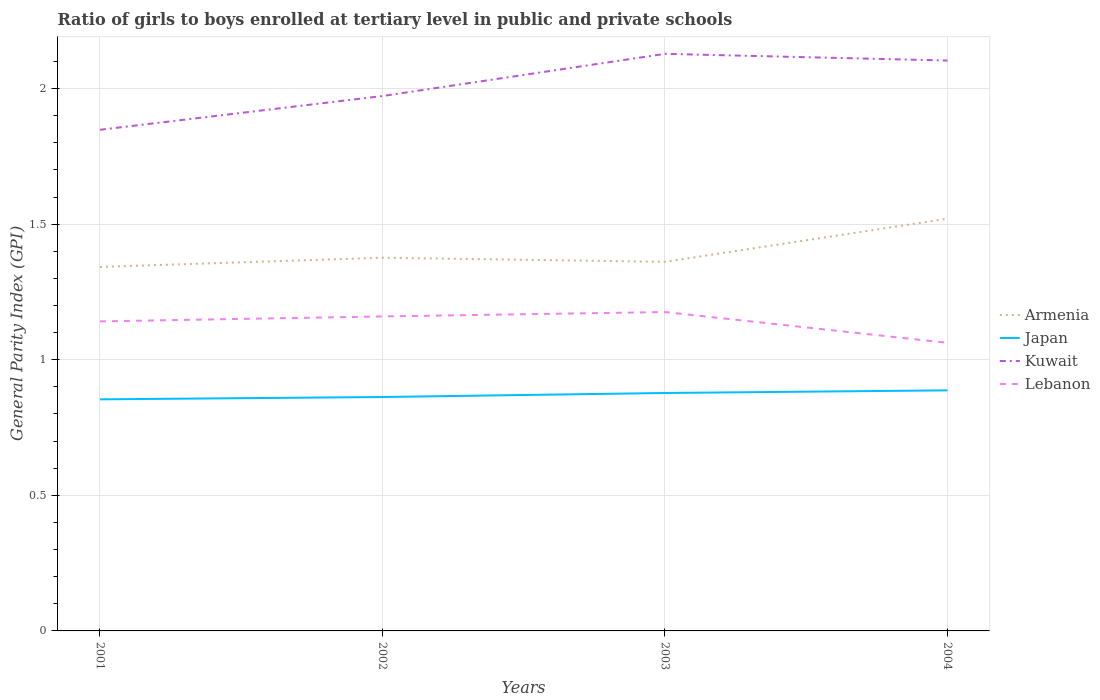Does the line corresponding to Lebanon intersect with the line corresponding to Japan?
Provide a short and direct response. No. Across all years, what is the maximum general parity index in Kuwait?
Offer a very short reply. 1.85. In which year was the general parity index in Lebanon maximum?
Your answer should be compact. 2004. What is the total general parity index in Kuwait in the graph?
Make the answer very short. -0.26. What is the difference between the highest and the second highest general parity index in Japan?
Offer a terse response. 0.03. What is the difference between the highest and the lowest general parity index in Lebanon?
Keep it short and to the point. 3. Is the general parity index in Kuwait strictly greater than the general parity index in Armenia over the years?
Offer a very short reply. No. How many lines are there?
Your answer should be compact. 4. How many years are there in the graph?
Keep it short and to the point. 4. What is the difference between two consecutive major ticks on the Y-axis?
Give a very brief answer. 0.5. Are the values on the major ticks of Y-axis written in scientific E-notation?
Your answer should be very brief. No. Does the graph contain any zero values?
Keep it short and to the point. No. Where does the legend appear in the graph?
Provide a short and direct response. Center right. How many legend labels are there?
Give a very brief answer. 4. What is the title of the graph?
Offer a terse response. Ratio of girls to boys enrolled at tertiary level in public and private schools. What is the label or title of the Y-axis?
Offer a very short reply. General Parity Index (GPI). What is the General Parity Index (GPI) of Armenia in 2001?
Give a very brief answer. 1.34. What is the General Parity Index (GPI) of Japan in 2001?
Your response must be concise. 0.85. What is the General Parity Index (GPI) in Kuwait in 2001?
Make the answer very short. 1.85. What is the General Parity Index (GPI) in Lebanon in 2001?
Offer a terse response. 1.14. What is the General Parity Index (GPI) in Armenia in 2002?
Your answer should be very brief. 1.38. What is the General Parity Index (GPI) in Japan in 2002?
Make the answer very short. 0.86. What is the General Parity Index (GPI) in Kuwait in 2002?
Offer a very short reply. 1.97. What is the General Parity Index (GPI) in Lebanon in 2002?
Offer a very short reply. 1.16. What is the General Parity Index (GPI) of Armenia in 2003?
Your answer should be very brief. 1.36. What is the General Parity Index (GPI) in Japan in 2003?
Your response must be concise. 0.88. What is the General Parity Index (GPI) in Kuwait in 2003?
Offer a terse response. 2.13. What is the General Parity Index (GPI) in Lebanon in 2003?
Your response must be concise. 1.18. What is the General Parity Index (GPI) in Armenia in 2004?
Provide a short and direct response. 1.52. What is the General Parity Index (GPI) of Japan in 2004?
Offer a terse response. 0.89. What is the General Parity Index (GPI) in Kuwait in 2004?
Ensure brevity in your answer.  2.1. What is the General Parity Index (GPI) in Lebanon in 2004?
Your response must be concise. 1.06. Across all years, what is the maximum General Parity Index (GPI) of Armenia?
Keep it short and to the point. 1.52. Across all years, what is the maximum General Parity Index (GPI) of Japan?
Your answer should be very brief. 0.89. Across all years, what is the maximum General Parity Index (GPI) in Kuwait?
Offer a terse response. 2.13. Across all years, what is the maximum General Parity Index (GPI) of Lebanon?
Make the answer very short. 1.18. Across all years, what is the minimum General Parity Index (GPI) in Armenia?
Give a very brief answer. 1.34. Across all years, what is the minimum General Parity Index (GPI) of Japan?
Your response must be concise. 0.85. Across all years, what is the minimum General Parity Index (GPI) in Kuwait?
Make the answer very short. 1.85. Across all years, what is the minimum General Parity Index (GPI) in Lebanon?
Keep it short and to the point. 1.06. What is the total General Parity Index (GPI) in Armenia in the graph?
Offer a terse response. 5.6. What is the total General Parity Index (GPI) in Japan in the graph?
Provide a short and direct response. 3.48. What is the total General Parity Index (GPI) in Kuwait in the graph?
Provide a succinct answer. 8.05. What is the total General Parity Index (GPI) in Lebanon in the graph?
Give a very brief answer. 4.54. What is the difference between the General Parity Index (GPI) in Armenia in 2001 and that in 2002?
Give a very brief answer. -0.03. What is the difference between the General Parity Index (GPI) of Japan in 2001 and that in 2002?
Ensure brevity in your answer.  -0.01. What is the difference between the General Parity Index (GPI) of Kuwait in 2001 and that in 2002?
Provide a succinct answer. -0.12. What is the difference between the General Parity Index (GPI) of Lebanon in 2001 and that in 2002?
Give a very brief answer. -0.02. What is the difference between the General Parity Index (GPI) of Armenia in 2001 and that in 2003?
Provide a short and direct response. -0.02. What is the difference between the General Parity Index (GPI) in Japan in 2001 and that in 2003?
Provide a short and direct response. -0.02. What is the difference between the General Parity Index (GPI) in Kuwait in 2001 and that in 2003?
Your answer should be very brief. -0.28. What is the difference between the General Parity Index (GPI) of Lebanon in 2001 and that in 2003?
Offer a terse response. -0.03. What is the difference between the General Parity Index (GPI) in Armenia in 2001 and that in 2004?
Your answer should be very brief. -0.18. What is the difference between the General Parity Index (GPI) of Japan in 2001 and that in 2004?
Make the answer very short. -0.03. What is the difference between the General Parity Index (GPI) in Kuwait in 2001 and that in 2004?
Offer a very short reply. -0.26. What is the difference between the General Parity Index (GPI) of Lebanon in 2001 and that in 2004?
Keep it short and to the point. 0.08. What is the difference between the General Parity Index (GPI) in Armenia in 2002 and that in 2003?
Your answer should be compact. 0.02. What is the difference between the General Parity Index (GPI) of Japan in 2002 and that in 2003?
Your answer should be compact. -0.01. What is the difference between the General Parity Index (GPI) of Kuwait in 2002 and that in 2003?
Give a very brief answer. -0.16. What is the difference between the General Parity Index (GPI) of Lebanon in 2002 and that in 2003?
Offer a terse response. -0.02. What is the difference between the General Parity Index (GPI) of Armenia in 2002 and that in 2004?
Keep it short and to the point. -0.14. What is the difference between the General Parity Index (GPI) of Japan in 2002 and that in 2004?
Offer a very short reply. -0.02. What is the difference between the General Parity Index (GPI) of Kuwait in 2002 and that in 2004?
Your answer should be compact. -0.13. What is the difference between the General Parity Index (GPI) in Lebanon in 2002 and that in 2004?
Make the answer very short. 0.1. What is the difference between the General Parity Index (GPI) of Armenia in 2003 and that in 2004?
Give a very brief answer. -0.16. What is the difference between the General Parity Index (GPI) in Japan in 2003 and that in 2004?
Offer a very short reply. -0.01. What is the difference between the General Parity Index (GPI) of Kuwait in 2003 and that in 2004?
Offer a very short reply. 0.02. What is the difference between the General Parity Index (GPI) in Lebanon in 2003 and that in 2004?
Your answer should be compact. 0.11. What is the difference between the General Parity Index (GPI) in Armenia in 2001 and the General Parity Index (GPI) in Japan in 2002?
Your response must be concise. 0.48. What is the difference between the General Parity Index (GPI) in Armenia in 2001 and the General Parity Index (GPI) in Kuwait in 2002?
Offer a very short reply. -0.63. What is the difference between the General Parity Index (GPI) of Armenia in 2001 and the General Parity Index (GPI) of Lebanon in 2002?
Your response must be concise. 0.18. What is the difference between the General Parity Index (GPI) of Japan in 2001 and the General Parity Index (GPI) of Kuwait in 2002?
Offer a terse response. -1.12. What is the difference between the General Parity Index (GPI) of Japan in 2001 and the General Parity Index (GPI) of Lebanon in 2002?
Your answer should be compact. -0.31. What is the difference between the General Parity Index (GPI) of Kuwait in 2001 and the General Parity Index (GPI) of Lebanon in 2002?
Your answer should be very brief. 0.69. What is the difference between the General Parity Index (GPI) in Armenia in 2001 and the General Parity Index (GPI) in Japan in 2003?
Your answer should be compact. 0.46. What is the difference between the General Parity Index (GPI) in Armenia in 2001 and the General Parity Index (GPI) in Kuwait in 2003?
Your answer should be compact. -0.79. What is the difference between the General Parity Index (GPI) of Armenia in 2001 and the General Parity Index (GPI) of Lebanon in 2003?
Ensure brevity in your answer.  0.17. What is the difference between the General Parity Index (GPI) of Japan in 2001 and the General Parity Index (GPI) of Kuwait in 2003?
Provide a short and direct response. -1.27. What is the difference between the General Parity Index (GPI) of Japan in 2001 and the General Parity Index (GPI) of Lebanon in 2003?
Your answer should be very brief. -0.32. What is the difference between the General Parity Index (GPI) in Kuwait in 2001 and the General Parity Index (GPI) in Lebanon in 2003?
Give a very brief answer. 0.67. What is the difference between the General Parity Index (GPI) in Armenia in 2001 and the General Parity Index (GPI) in Japan in 2004?
Your answer should be very brief. 0.46. What is the difference between the General Parity Index (GPI) in Armenia in 2001 and the General Parity Index (GPI) in Kuwait in 2004?
Ensure brevity in your answer.  -0.76. What is the difference between the General Parity Index (GPI) in Armenia in 2001 and the General Parity Index (GPI) in Lebanon in 2004?
Give a very brief answer. 0.28. What is the difference between the General Parity Index (GPI) of Japan in 2001 and the General Parity Index (GPI) of Kuwait in 2004?
Make the answer very short. -1.25. What is the difference between the General Parity Index (GPI) in Japan in 2001 and the General Parity Index (GPI) in Lebanon in 2004?
Make the answer very short. -0.21. What is the difference between the General Parity Index (GPI) in Kuwait in 2001 and the General Parity Index (GPI) in Lebanon in 2004?
Keep it short and to the point. 0.79. What is the difference between the General Parity Index (GPI) in Armenia in 2002 and the General Parity Index (GPI) in Japan in 2003?
Make the answer very short. 0.5. What is the difference between the General Parity Index (GPI) in Armenia in 2002 and the General Parity Index (GPI) in Kuwait in 2003?
Make the answer very short. -0.75. What is the difference between the General Parity Index (GPI) of Armenia in 2002 and the General Parity Index (GPI) of Lebanon in 2003?
Offer a terse response. 0.2. What is the difference between the General Parity Index (GPI) in Japan in 2002 and the General Parity Index (GPI) in Kuwait in 2003?
Give a very brief answer. -1.27. What is the difference between the General Parity Index (GPI) in Japan in 2002 and the General Parity Index (GPI) in Lebanon in 2003?
Make the answer very short. -0.31. What is the difference between the General Parity Index (GPI) of Kuwait in 2002 and the General Parity Index (GPI) of Lebanon in 2003?
Make the answer very short. 0.8. What is the difference between the General Parity Index (GPI) of Armenia in 2002 and the General Parity Index (GPI) of Japan in 2004?
Provide a short and direct response. 0.49. What is the difference between the General Parity Index (GPI) in Armenia in 2002 and the General Parity Index (GPI) in Kuwait in 2004?
Ensure brevity in your answer.  -0.73. What is the difference between the General Parity Index (GPI) in Armenia in 2002 and the General Parity Index (GPI) in Lebanon in 2004?
Keep it short and to the point. 0.31. What is the difference between the General Parity Index (GPI) in Japan in 2002 and the General Parity Index (GPI) in Kuwait in 2004?
Your answer should be very brief. -1.24. What is the difference between the General Parity Index (GPI) of Japan in 2002 and the General Parity Index (GPI) of Lebanon in 2004?
Ensure brevity in your answer.  -0.2. What is the difference between the General Parity Index (GPI) in Kuwait in 2002 and the General Parity Index (GPI) in Lebanon in 2004?
Provide a short and direct response. 0.91. What is the difference between the General Parity Index (GPI) of Armenia in 2003 and the General Parity Index (GPI) of Japan in 2004?
Make the answer very short. 0.47. What is the difference between the General Parity Index (GPI) of Armenia in 2003 and the General Parity Index (GPI) of Kuwait in 2004?
Provide a succinct answer. -0.74. What is the difference between the General Parity Index (GPI) in Armenia in 2003 and the General Parity Index (GPI) in Lebanon in 2004?
Keep it short and to the point. 0.3. What is the difference between the General Parity Index (GPI) of Japan in 2003 and the General Parity Index (GPI) of Kuwait in 2004?
Ensure brevity in your answer.  -1.23. What is the difference between the General Parity Index (GPI) of Japan in 2003 and the General Parity Index (GPI) of Lebanon in 2004?
Offer a terse response. -0.18. What is the difference between the General Parity Index (GPI) in Kuwait in 2003 and the General Parity Index (GPI) in Lebanon in 2004?
Your answer should be very brief. 1.07. What is the average General Parity Index (GPI) of Armenia per year?
Your answer should be very brief. 1.4. What is the average General Parity Index (GPI) of Japan per year?
Keep it short and to the point. 0.87. What is the average General Parity Index (GPI) in Kuwait per year?
Provide a short and direct response. 2.01. What is the average General Parity Index (GPI) in Lebanon per year?
Your answer should be compact. 1.13. In the year 2001, what is the difference between the General Parity Index (GPI) of Armenia and General Parity Index (GPI) of Japan?
Your response must be concise. 0.49. In the year 2001, what is the difference between the General Parity Index (GPI) in Armenia and General Parity Index (GPI) in Kuwait?
Keep it short and to the point. -0.51. In the year 2001, what is the difference between the General Parity Index (GPI) of Armenia and General Parity Index (GPI) of Lebanon?
Offer a terse response. 0.2. In the year 2001, what is the difference between the General Parity Index (GPI) in Japan and General Parity Index (GPI) in Kuwait?
Provide a succinct answer. -0.99. In the year 2001, what is the difference between the General Parity Index (GPI) in Japan and General Parity Index (GPI) in Lebanon?
Offer a very short reply. -0.29. In the year 2001, what is the difference between the General Parity Index (GPI) in Kuwait and General Parity Index (GPI) in Lebanon?
Make the answer very short. 0.71. In the year 2002, what is the difference between the General Parity Index (GPI) in Armenia and General Parity Index (GPI) in Japan?
Your answer should be compact. 0.51. In the year 2002, what is the difference between the General Parity Index (GPI) of Armenia and General Parity Index (GPI) of Kuwait?
Your answer should be compact. -0.6. In the year 2002, what is the difference between the General Parity Index (GPI) in Armenia and General Parity Index (GPI) in Lebanon?
Offer a very short reply. 0.22. In the year 2002, what is the difference between the General Parity Index (GPI) of Japan and General Parity Index (GPI) of Kuwait?
Provide a succinct answer. -1.11. In the year 2002, what is the difference between the General Parity Index (GPI) of Japan and General Parity Index (GPI) of Lebanon?
Make the answer very short. -0.3. In the year 2002, what is the difference between the General Parity Index (GPI) of Kuwait and General Parity Index (GPI) of Lebanon?
Your answer should be very brief. 0.81. In the year 2003, what is the difference between the General Parity Index (GPI) in Armenia and General Parity Index (GPI) in Japan?
Provide a succinct answer. 0.48. In the year 2003, what is the difference between the General Parity Index (GPI) in Armenia and General Parity Index (GPI) in Kuwait?
Your answer should be very brief. -0.77. In the year 2003, what is the difference between the General Parity Index (GPI) of Armenia and General Parity Index (GPI) of Lebanon?
Provide a short and direct response. 0.19. In the year 2003, what is the difference between the General Parity Index (GPI) in Japan and General Parity Index (GPI) in Kuwait?
Your answer should be compact. -1.25. In the year 2003, what is the difference between the General Parity Index (GPI) of Japan and General Parity Index (GPI) of Lebanon?
Give a very brief answer. -0.3. In the year 2003, what is the difference between the General Parity Index (GPI) in Kuwait and General Parity Index (GPI) in Lebanon?
Provide a short and direct response. 0.95. In the year 2004, what is the difference between the General Parity Index (GPI) in Armenia and General Parity Index (GPI) in Japan?
Make the answer very short. 0.63. In the year 2004, what is the difference between the General Parity Index (GPI) of Armenia and General Parity Index (GPI) of Kuwait?
Provide a short and direct response. -0.58. In the year 2004, what is the difference between the General Parity Index (GPI) of Armenia and General Parity Index (GPI) of Lebanon?
Give a very brief answer. 0.46. In the year 2004, what is the difference between the General Parity Index (GPI) of Japan and General Parity Index (GPI) of Kuwait?
Provide a short and direct response. -1.22. In the year 2004, what is the difference between the General Parity Index (GPI) in Japan and General Parity Index (GPI) in Lebanon?
Provide a succinct answer. -0.18. In the year 2004, what is the difference between the General Parity Index (GPI) in Kuwait and General Parity Index (GPI) in Lebanon?
Give a very brief answer. 1.04. What is the ratio of the General Parity Index (GPI) in Armenia in 2001 to that in 2002?
Offer a terse response. 0.98. What is the ratio of the General Parity Index (GPI) in Kuwait in 2001 to that in 2002?
Provide a succinct answer. 0.94. What is the ratio of the General Parity Index (GPI) in Lebanon in 2001 to that in 2002?
Keep it short and to the point. 0.98. What is the ratio of the General Parity Index (GPI) of Armenia in 2001 to that in 2003?
Ensure brevity in your answer.  0.99. What is the ratio of the General Parity Index (GPI) of Japan in 2001 to that in 2003?
Give a very brief answer. 0.97. What is the ratio of the General Parity Index (GPI) in Kuwait in 2001 to that in 2003?
Provide a succinct answer. 0.87. What is the ratio of the General Parity Index (GPI) of Lebanon in 2001 to that in 2003?
Your answer should be very brief. 0.97. What is the ratio of the General Parity Index (GPI) in Armenia in 2001 to that in 2004?
Keep it short and to the point. 0.88. What is the ratio of the General Parity Index (GPI) of Japan in 2001 to that in 2004?
Give a very brief answer. 0.96. What is the ratio of the General Parity Index (GPI) in Kuwait in 2001 to that in 2004?
Offer a terse response. 0.88. What is the ratio of the General Parity Index (GPI) of Lebanon in 2001 to that in 2004?
Provide a short and direct response. 1.07. What is the ratio of the General Parity Index (GPI) of Armenia in 2002 to that in 2003?
Provide a short and direct response. 1.01. What is the ratio of the General Parity Index (GPI) of Japan in 2002 to that in 2003?
Give a very brief answer. 0.98. What is the ratio of the General Parity Index (GPI) of Kuwait in 2002 to that in 2003?
Make the answer very short. 0.93. What is the ratio of the General Parity Index (GPI) of Lebanon in 2002 to that in 2003?
Your answer should be very brief. 0.99. What is the ratio of the General Parity Index (GPI) of Armenia in 2002 to that in 2004?
Offer a very short reply. 0.91. What is the ratio of the General Parity Index (GPI) of Japan in 2002 to that in 2004?
Your answer should be compact. 0.97. What is the ratio of the General Parity Index (GPI) of Kuwait in 2002 to that in 2004?
Keep it short and to the point. 0.94. What is the ratio of the General Parity Index (GPI) of Lebanon in 2002 to that in 2004?
Ensure brevity in your answer.  1.09. What is the ratio of the General Parity Index (GPI) of Armenia in 2003 to that in 2004?
Give a very brief answer. 0.9. What is the ratio of the General Parity Index (GPI) in Kuwait in 2003 to that in 2004?
Your answer should be very brief. 1.01. What is the ratio of the General Parity Index (GPI) in Lebanon in 2003 to that in 2004?
Offer a terse response. 1.11. What is the difference between the highest and the second highest General Parity Index (GPI) of Armenia?
Give a very brief answer. 0.14. What is the difference between the highest and the second highest General Parity Index (GPI) in Japan?
Ensure brevity in your answer.  0.01. What is the difference between the highest and the second highest General Parity Index (GPI) of Kuwait?
Your answer should be compact. 0.02. What is the difference between the highest and the second highest General Parity Index (GPI) in Lebanon?
Make the answer very short. 0.02. What is the difference between the highest and the lowest General Parity Index (GPI) of Armenia?
Make the answer very short. 0.18. What is the difference between the highest and the lowest General Parity Index (GPI) in Japan?
Ensure brevity in your answer.  0.03. What is the difference between the highest and the lowest General Parity Index (GPI) in Kuwait?
Provide a succinct answer. 0.28. What is the difference between the highest and the lowest General Parity Index (GPI) in Lebanon?
Offer a very short reply. 0.11. 